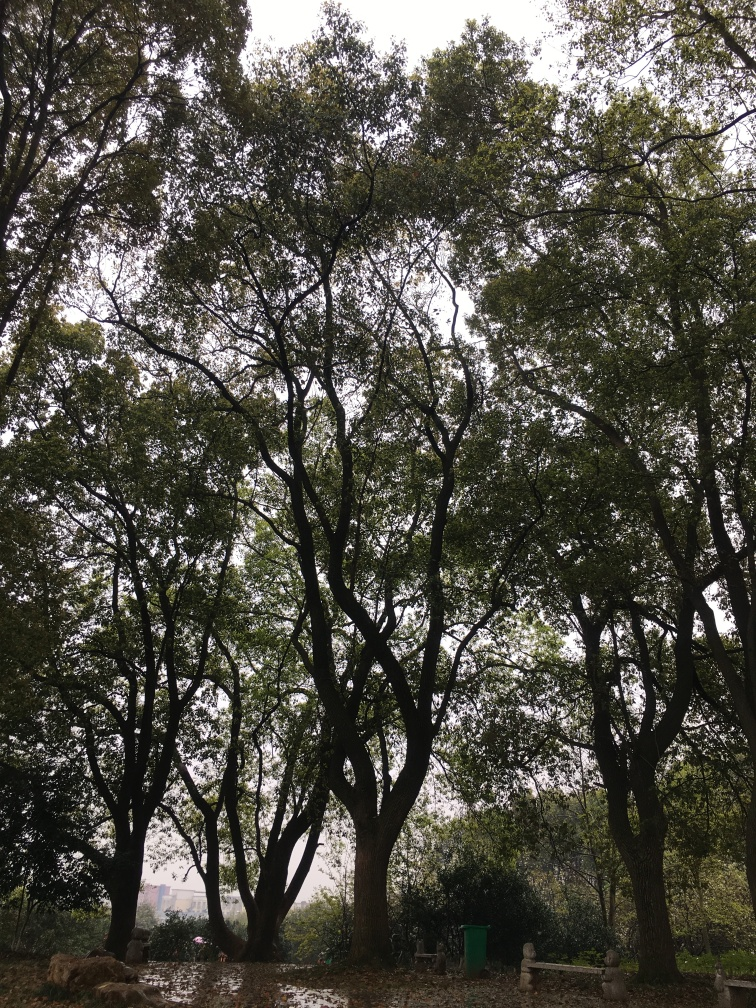What time of year does this photo appear to be taken in? The photo seems to be taken during a season where the trees are full of green leaves, possibly indicating late spring or summer. There's no sign of blossoms or autumnal colors, which can help narrow down the possibilities. 